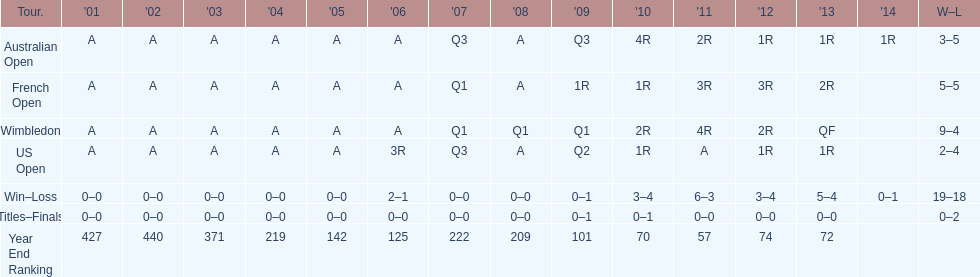What is the variation in wins between wimbledon and the us open for this competitor? 7. 